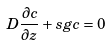Convert formula to latex. <formula><loc_0><loc_0><loc_500><loc_500>D \frac { \partial c } { \partial z } + s g c = 0</formula> 